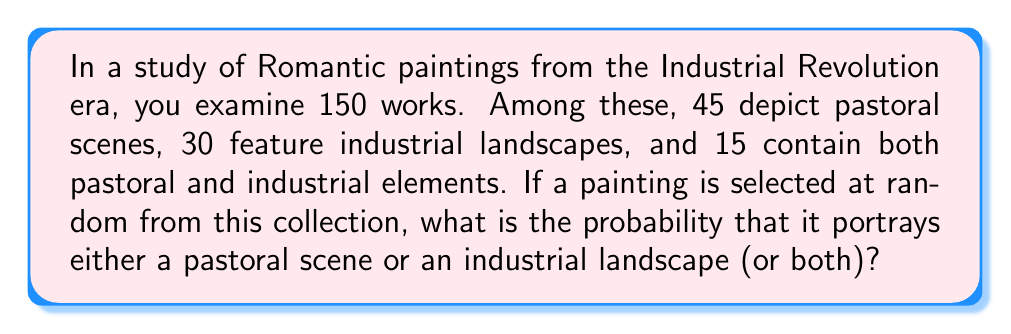What is the answer to this math problem? Let's approach this step-by-step using set theory and the addition rule of probability:

1) Let's define our events:
   P = event that a painting depicts a pastoral scene
   I = event that a painting features an industrial landscape

2) We're given the following information:
   - Total number of paintings: n(U) = 150
   - Number of paintings with pastoral scenes: n(P) = 45
   - Number of paintings with industrial landscapes: n(I) = 30
   - Number of paintings with both elements: n(P ∩ I) = 15

3) We need to find P(P ∪ I), the probability of a painting having either pastoral or industrial elements (or both).

4) We can use the addition rule of probability:
   
   P(P ∪ I) = P(P) + P(I) - P(P ∩ I)

5) Calculate each probability:
   
   P(P) = n(P) / n(U) = 45 / 150 = 0.3
   P(I) = n(I) / n(U) = 30 / 150 = 0.2
   P(P ∩ I) = n(P ∩ I) / n(U) = 15 / 150 = 0.1

6) Now, let's substitute these values into our equation:

   P(P ∪ I) = 0.3 + 0.2 - 0.1 = 0.4

Therefore, the probability of selecting a painting that portrays either a pastoral scene or an industrial landscape (or both) is 0.4 or 40%.
Answer: The probability is 0.4 or 40%. 